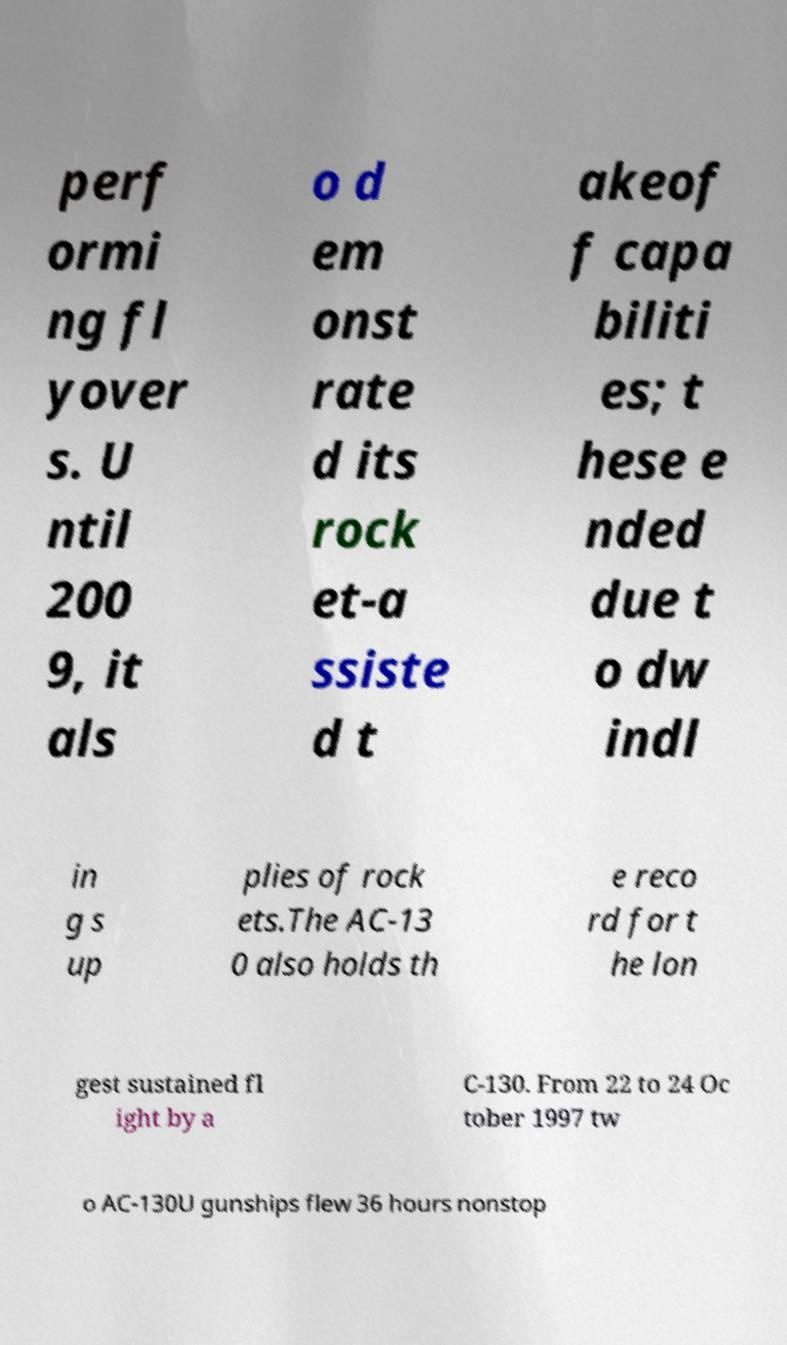I need the written content from this picture converted into text. Can you do that? perf ormi ng fl yover s. U ntil 200 9, it als o d em onst rate d its rock et-a ssiste d t akeof f capa biliti es; t hese e nded due t o dw indl in g s up plies of rock ets.The AC-13 0 also holds th e reco rd for t he lon gest sustained fl ight by a C-130. From 22 to 24 Oc tober 1997 tw o AC-130U gunships flew 36 hours nonstop 